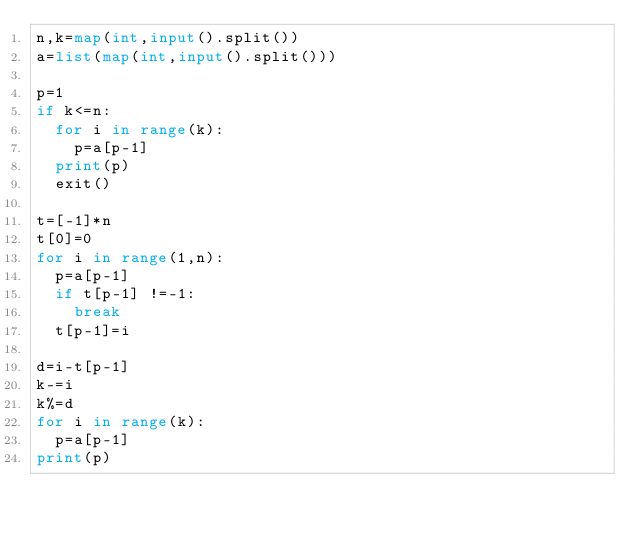<code> <loc_0><loc_0><loc_500><loc_500><_Python_>n,k=map(int,input().split())
a=list(map(int,input().split()))

p=1
if k<=n:
  for i in range(k):
    p=a[p-1]
  print(p)
  exit()

t=[-1]*n
t[0]=0
for i in range(1,n):
  p=a[p-1]
  if t[p-1] !=-1:
    break
  t[p-1]=i

d=i-t[p-1]
k-=i
k%=d
for i in range(k):
  p=a[p-1]
print(p)
</code> 